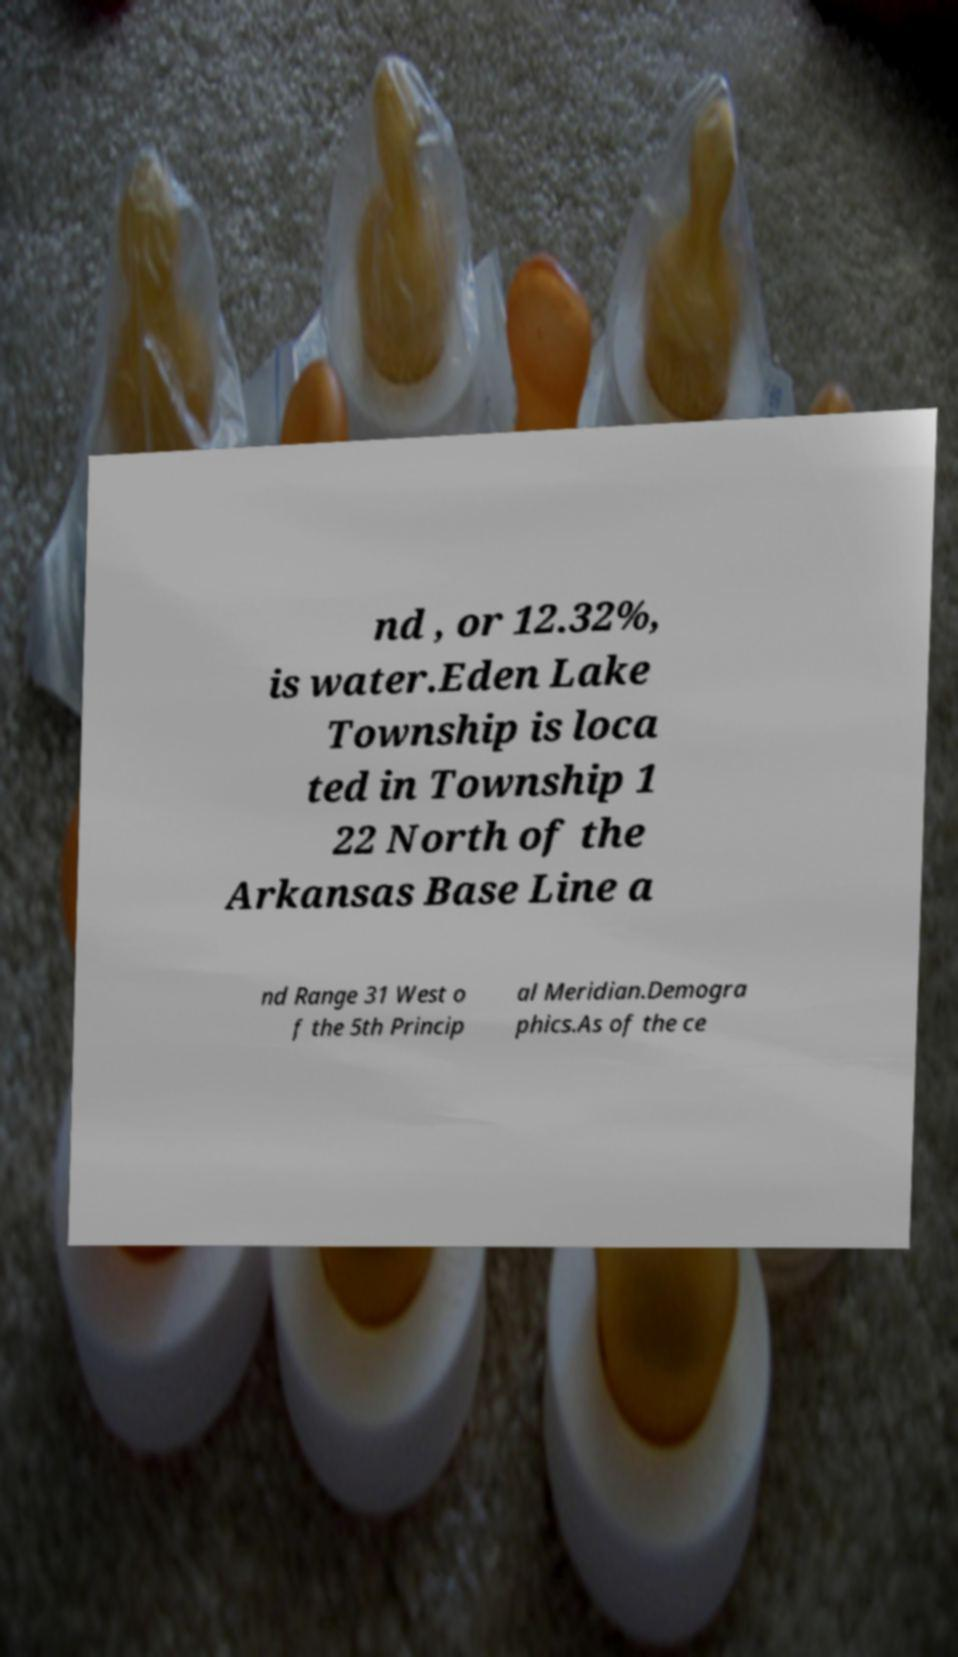Could you assist in decoding the text presented in this image and type it out clearly? nd , or 12.32%, is water.Eden Lake Township is loca ted in Township 1 22 North of the Arkansas Base Line a nd Range 31 West o f the 5th Princip al Meridian.Demogra phics.As of the ce 